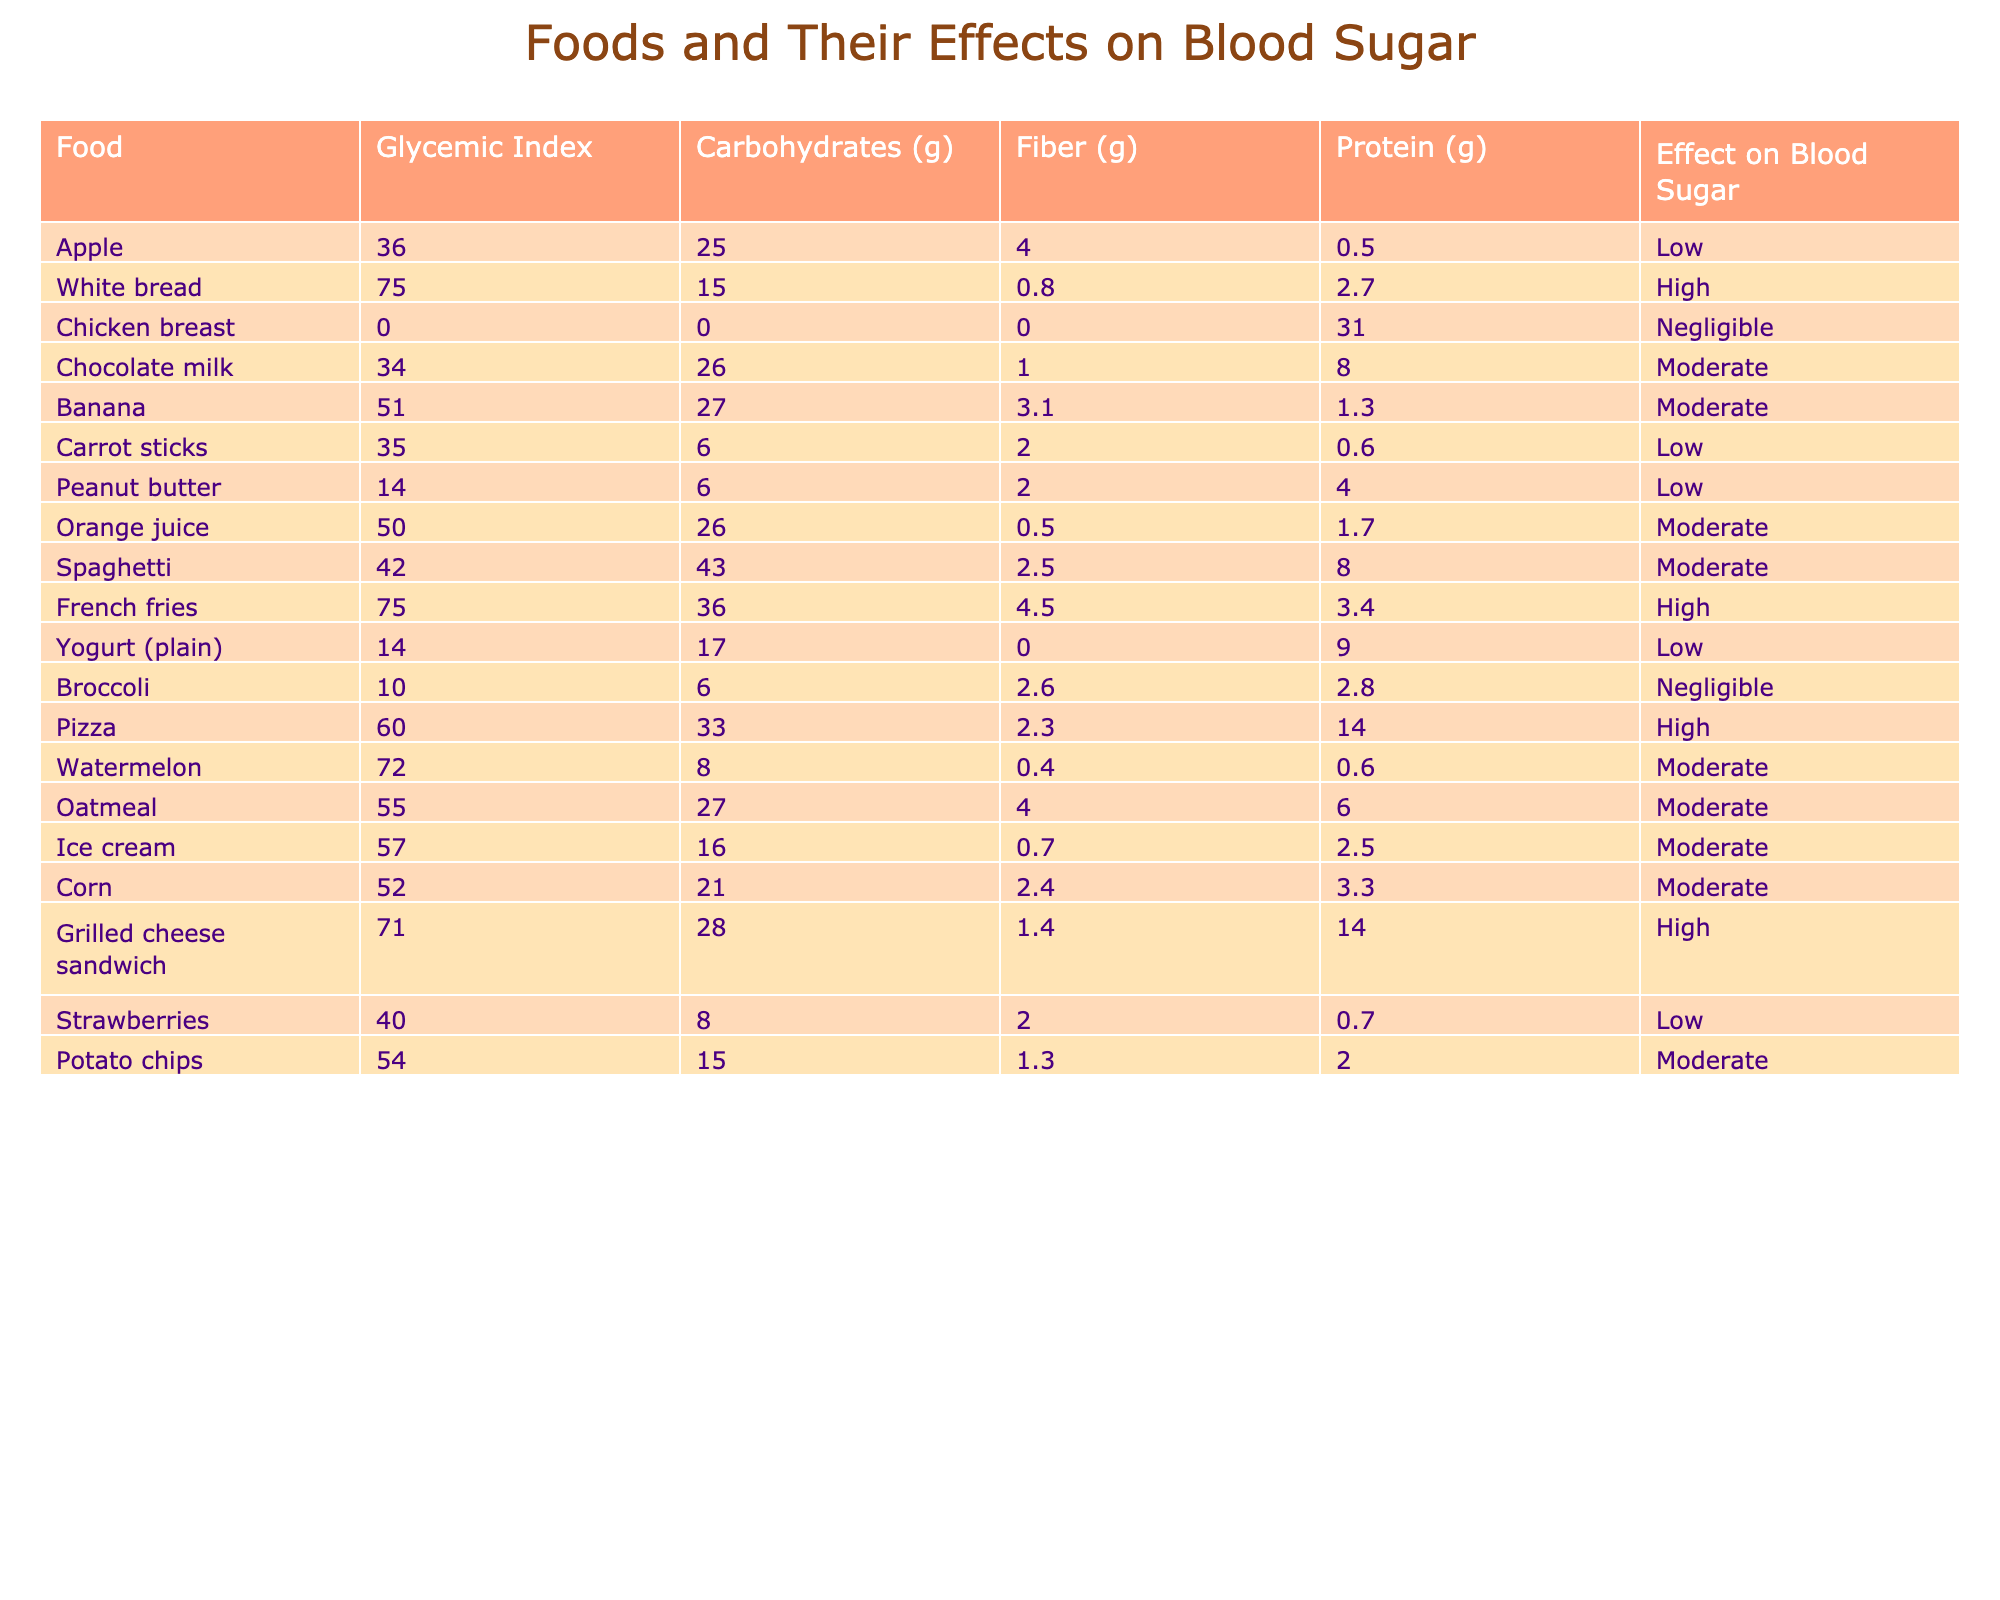What's the glycemic index of white bread? Referring to the table, the glycemic index for white bread is listed as 75.
Answer: 75 Which food has the highest amount of carbohydrates? Looking at the carbohydrates column in the table, spaghetti has the highest amount at 43 grams.
Answer: 43 grams Is chicken breast considered high in its effect on blood sugar? The effect on blood sugar for chicken breast is classified as negligible according to the table.
Answer: No How does the effect on blood sugar for yogurt (plain) compare to banana? The effect for yogurt is low and for banana is moderate, showing that banana affects blood sugar more.
Answer: Yogurt is low, banana is moderate What is the average glycemic index for the foods listed in the table? To calculate the average, add all the glycemic index values: 36 + 75 + 0 + 34 + 51 + 35 + 14 + 50 + 42 + 75 + 10 + 60 + 72 + 55 + 57 + 52 + 71 + 40 + 54 = 49. The total count is 18, so the average is 49/18 ≈ 49.
Answer: Approximately 49 Which food has the lowest protein content? The table shows that peanut butter has 4 grams, while the lowest protein content is found in carrot sticks with 0.6 grams.
Answer: Carrot sticks How many foods are listed as having a low effect on blood sugar? From the table, we identify 5 foods: apple, carrot sticks, peanut butter, yogurt (plain), and strawberries.
Answer: 5 foods Which food category has the highest effect on blood sugar overall? By examining the effects on blood sugar, both white bread and French fries are categorized as high. They have a significant impact compared to others.
Answer: High Does watermelon have more carbohydrates than carrot sticks? The table indicates that watermelon has 8 grams of carbohydrates, while carrot sticks have 6 grams, so yes, watermelon has more.
Answer: Yes If you avoid high blood sugar effects, which foods should you eat? Foods listed as having low or moderate effects include apple, carrot sticks, peanut butter, yogurt (plain), strawberries, and a few others with moderate effects listed in the table.
Answer: Low and moderate effect foods 